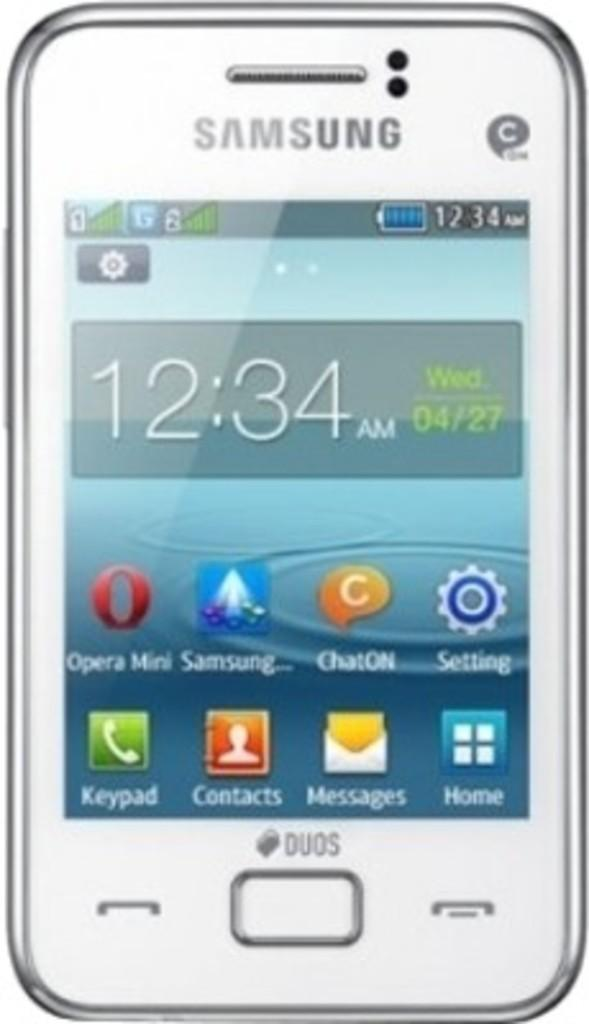Provide a one-sentence caption for the provided image. White samsung phone that shows the home screen. 